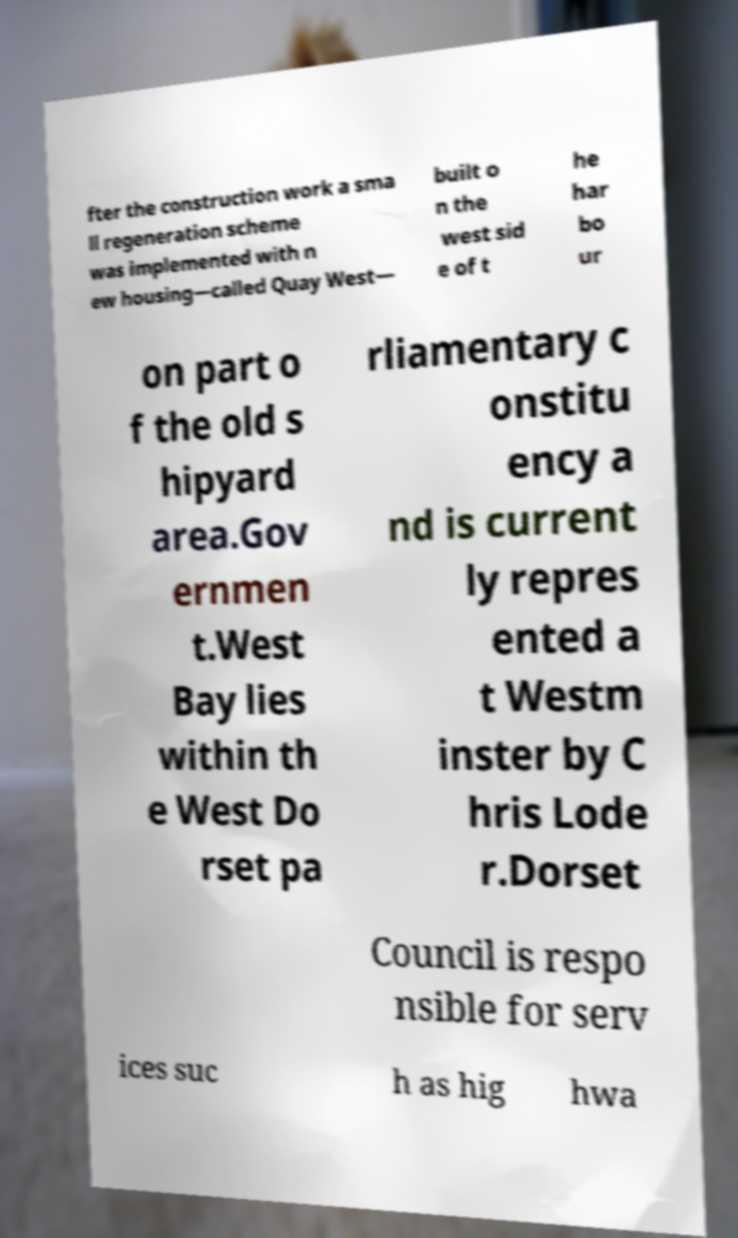Could you assist in decoding the text presented in this image and type it out clearly? fter the construction work a sma ll regeneration scheme was implemented with n ew housing—called Quay West— built o n the west sid e of t he har bo ur on part o f the old s hipyard area.Gov ernmen t.West Bay lies within th e West Do rset pa rliamentary c onstitu ency a nd is current ly repres ented a t Westm inster by C hris Lode r.Dorset Council is respo nsible for serv ices suc h as hig hwa 